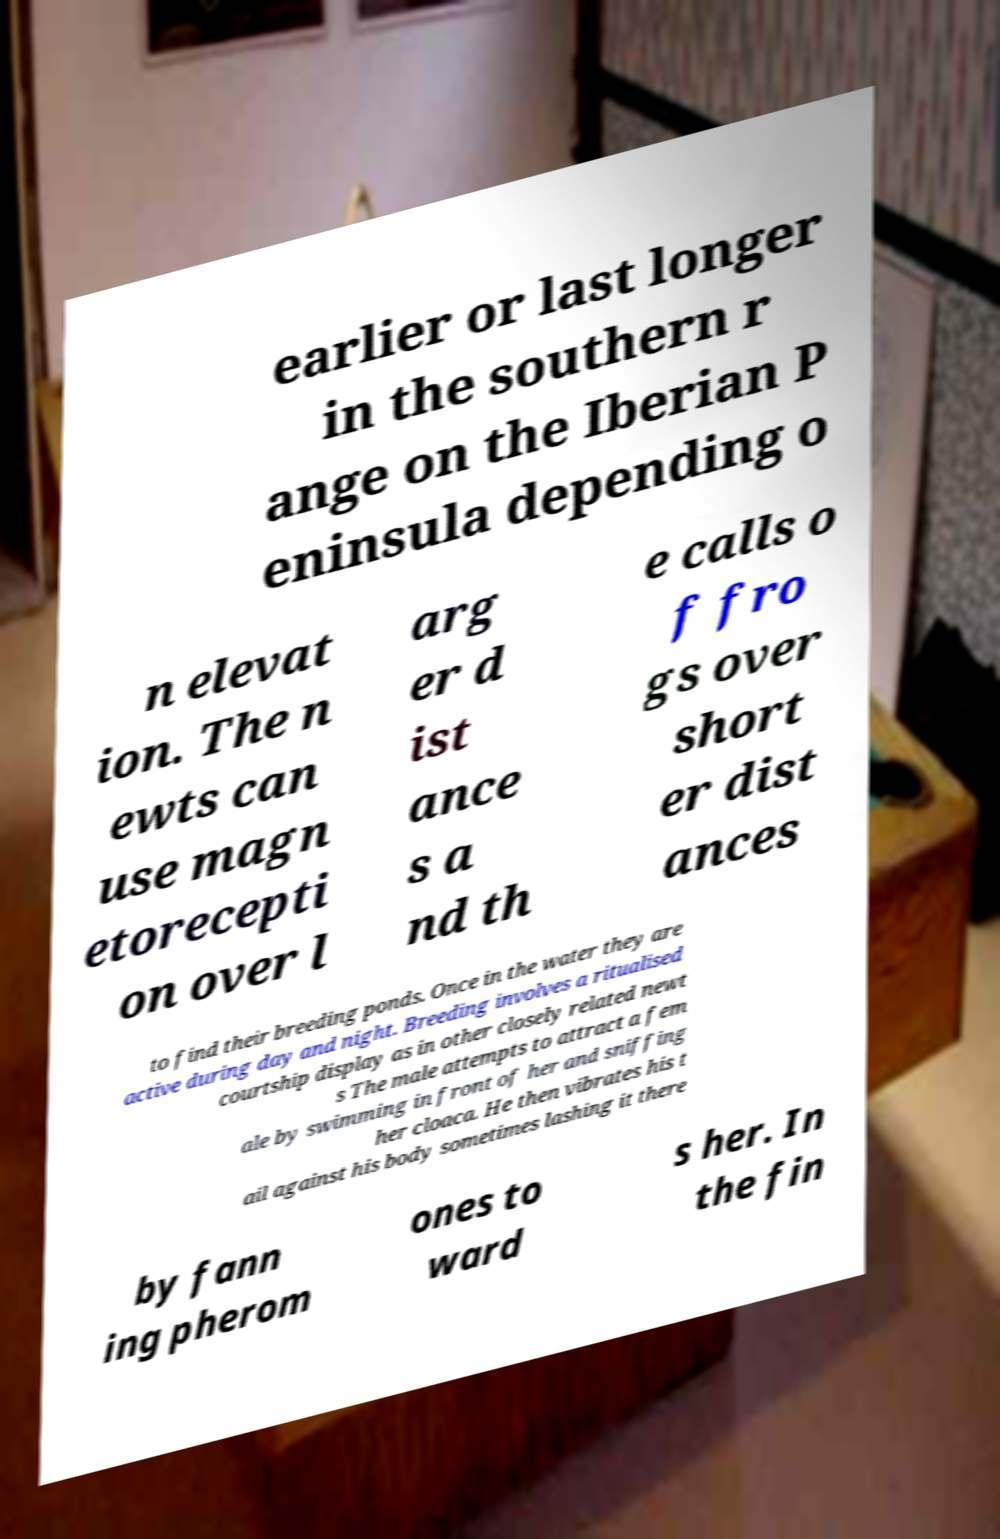Could you assist in decoding the text presented in this image and type it out clearly? earlier or last longer in the southern r ange on the Iberian P eninsula depending o n elevat ion. The n ewts can use magn etorecepti on over l arg er d ist ance s a nd th e calls o f fro gs over short er dist ances to find their breeding ponds. Once in the water they are active during day and night. Breeding involves a ritualised courtship display as in other closely related newt s The male attempts to attract a fem ale by swimming in front of her and sniffing her cloaca. He then vibrates his t ail against his body sometimes lashing it there by fann ing pherom ones to ward s her. In the fin 